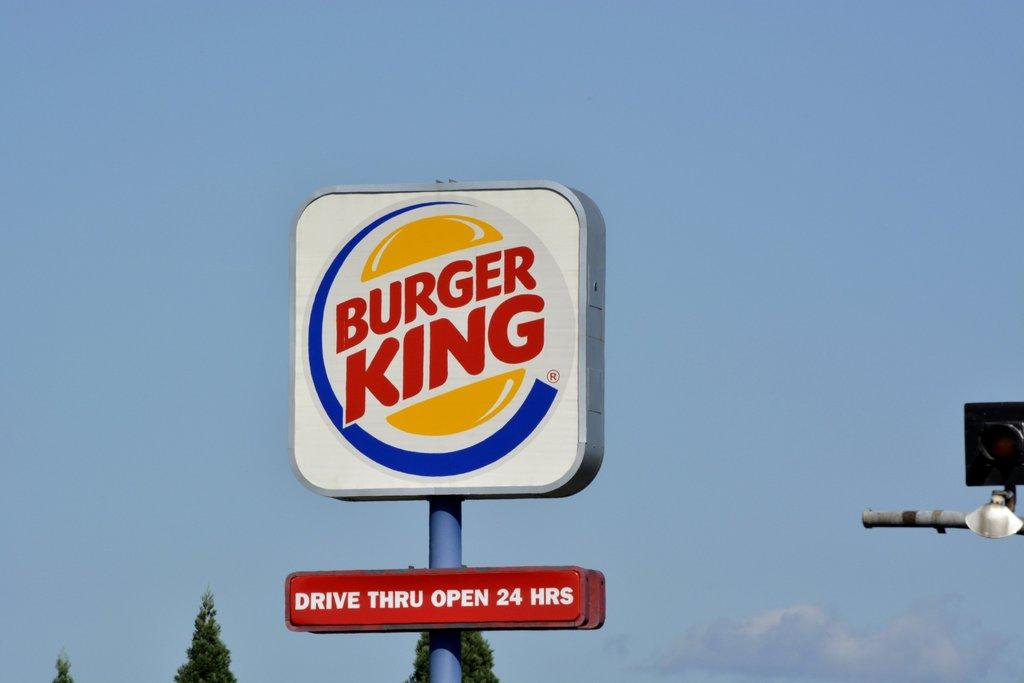<image>
Present a compact description of the photo's key features. A large outdoor Burger King sign against a blue sky. 